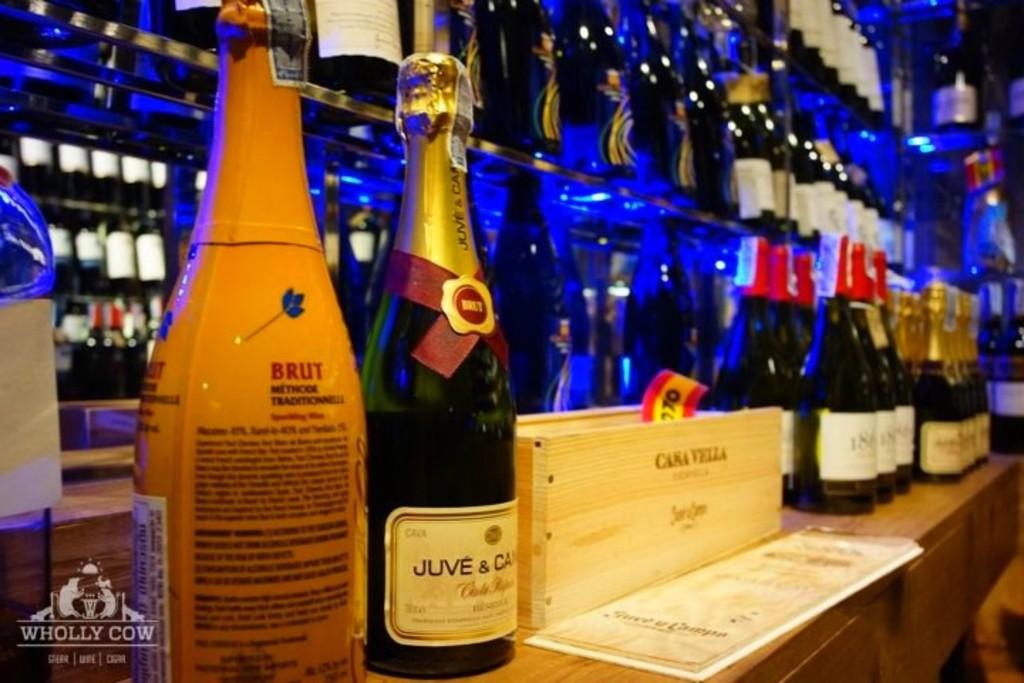What's the brand of the orange bottle?
Your answer should be compact. Brut. What kind of ale is this?
Give a very brief answer. Unanswerable. 